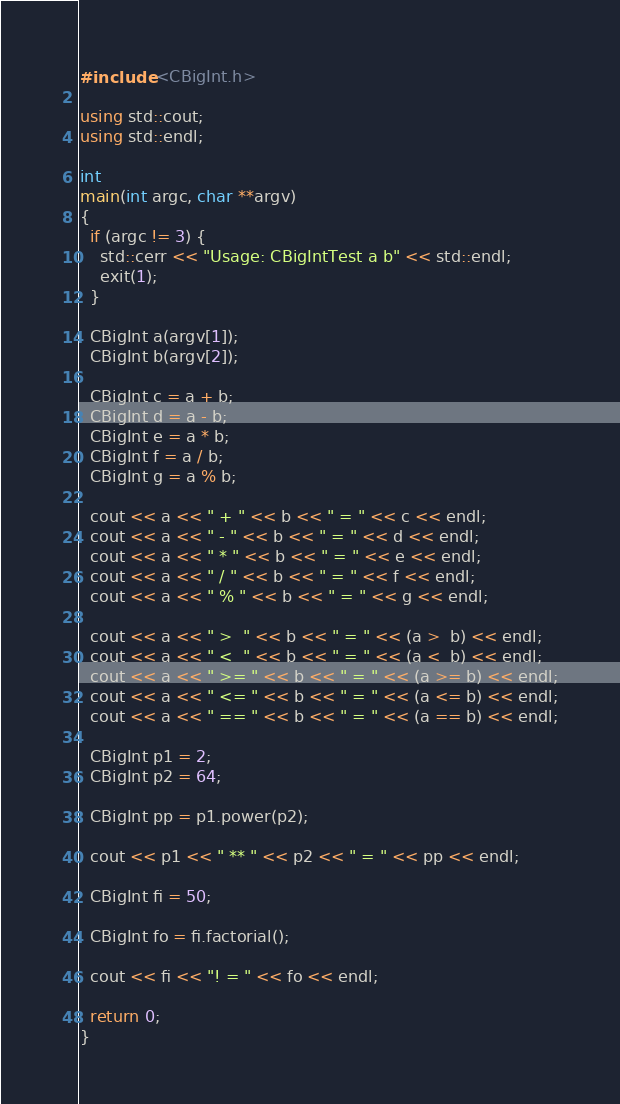<code> <loc_0><loc_0><loc_500><loc_500><_C++_>#include <CBigInt.h>

using std::cout;
using std::endl;

int
main(int argc, char **argv)
{
  if (argc != 3) {
    std::cerr << "Usage: CBigIntTest a b" << std::endl;
    exit(1);
  }

  CBigInt a(argv[1]);
  CBigInt b(argv[2]);

  CBigInt c = a + b;
  CBigInt d = a - b;
  CBigInt e = a * b;
  CBigInt f = a / b;
  CBigInt g = a % b;

  cout << a << " + " << b << " = " << c << endl;
  cout << a << " - " << b << " = " << d << endl;
  cout << a << " * " << b << " = " << e << endl;
  cout << a << " / " << b << " = " << f << endl;
  cout << a << " % " << b << " = " << g << endl;

  cout << a << " >  " << b << " = " << (a >  b) << endl;
  cout << a << " <  " << b << " = " << (a <  b) << endl;
  cout << a << " >= " << b << " = " << (a >= b) << endl;
  cout << a << " <= " << b << " = " << (a <= b) << endl;
  cout << a << " == " << b << " = " << (a == b) << endl;

  CBigInt p1 = 2;
  CBigInt p2 = 64;

  CBigInt pp = p1.power(p2);

  cout << p1 << " ** " << p2 << " = " << pp << endl;

  CBigInt fi = 50;

  CBigInt fo = fi.factorial();

  cout << fi << "! = " << fo << endl;

  return 0;
}
</code> 